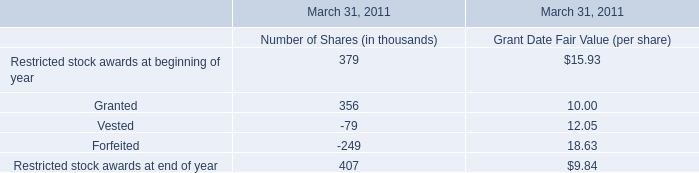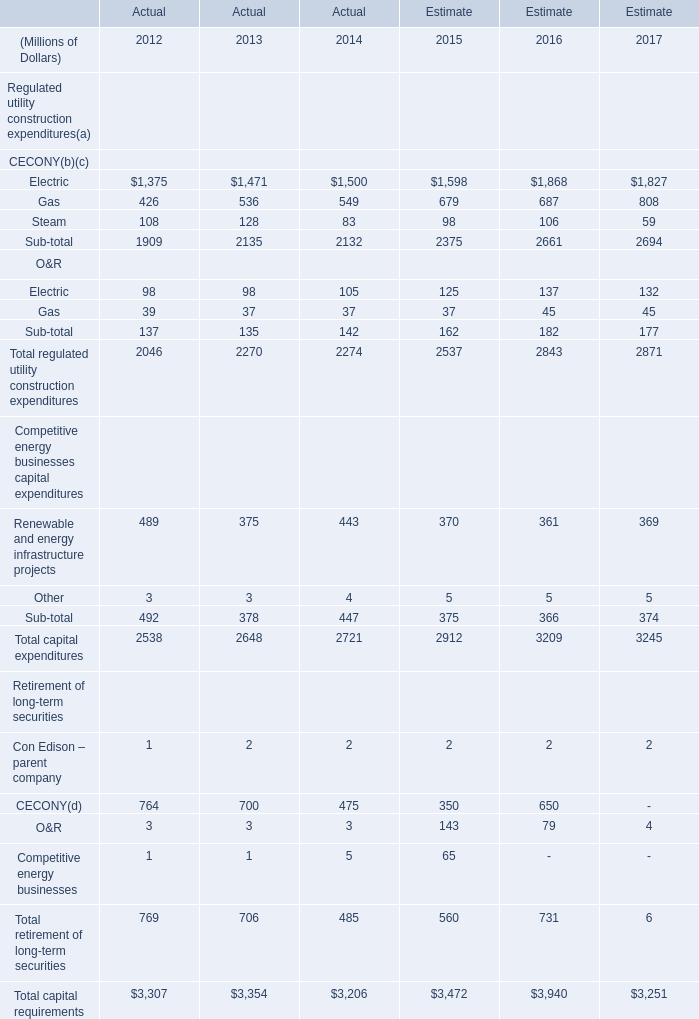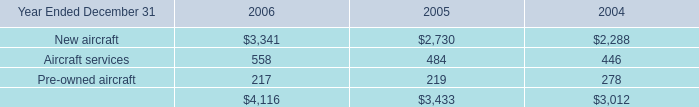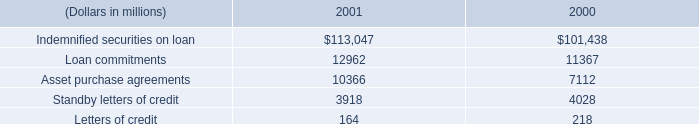what is the percentage change in the balance of letters of credit from 2000 to 2001? 
Computations: ((164 - 218) / 218)
Answer: -0.24771. 